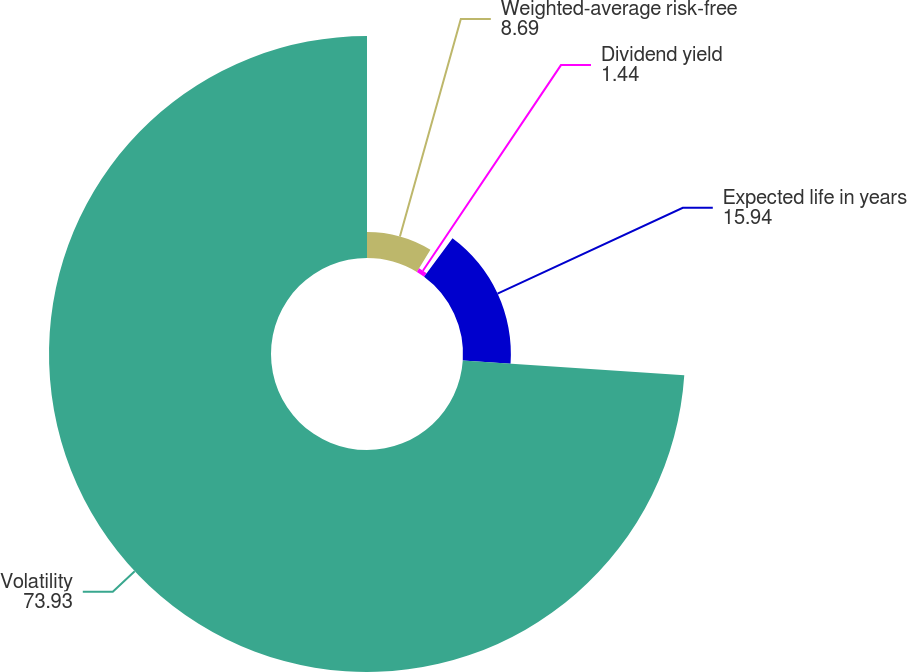<chart> <loc_0><loc_0><loc_500><loc_500><pie_chart><fcel>Weighted-average risk-free<fcel>Dividend yield<fcel>Expected life in years<fcel>Volatility<nl><fcel>8.69%<fcel>1.44%<fcel>15.94%<fcel>73.93%<nl></chart> 